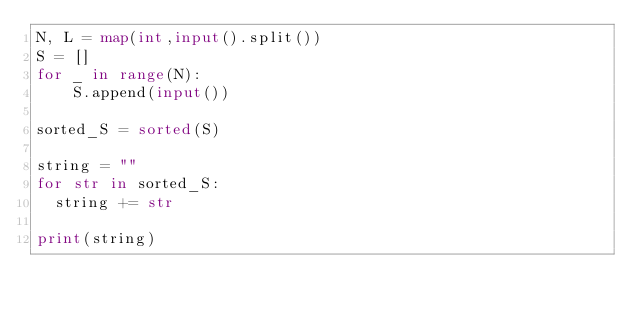<code> <loc_0><loc_0><loc_500><loc_500><_Python_>N, L = map(int,input().split())
S = []
for _ in range(N):
	S.append(input())

sorted_S = sorted(S)

string = ""
for str in sorted_S:
  string += str

print(string)</code> 